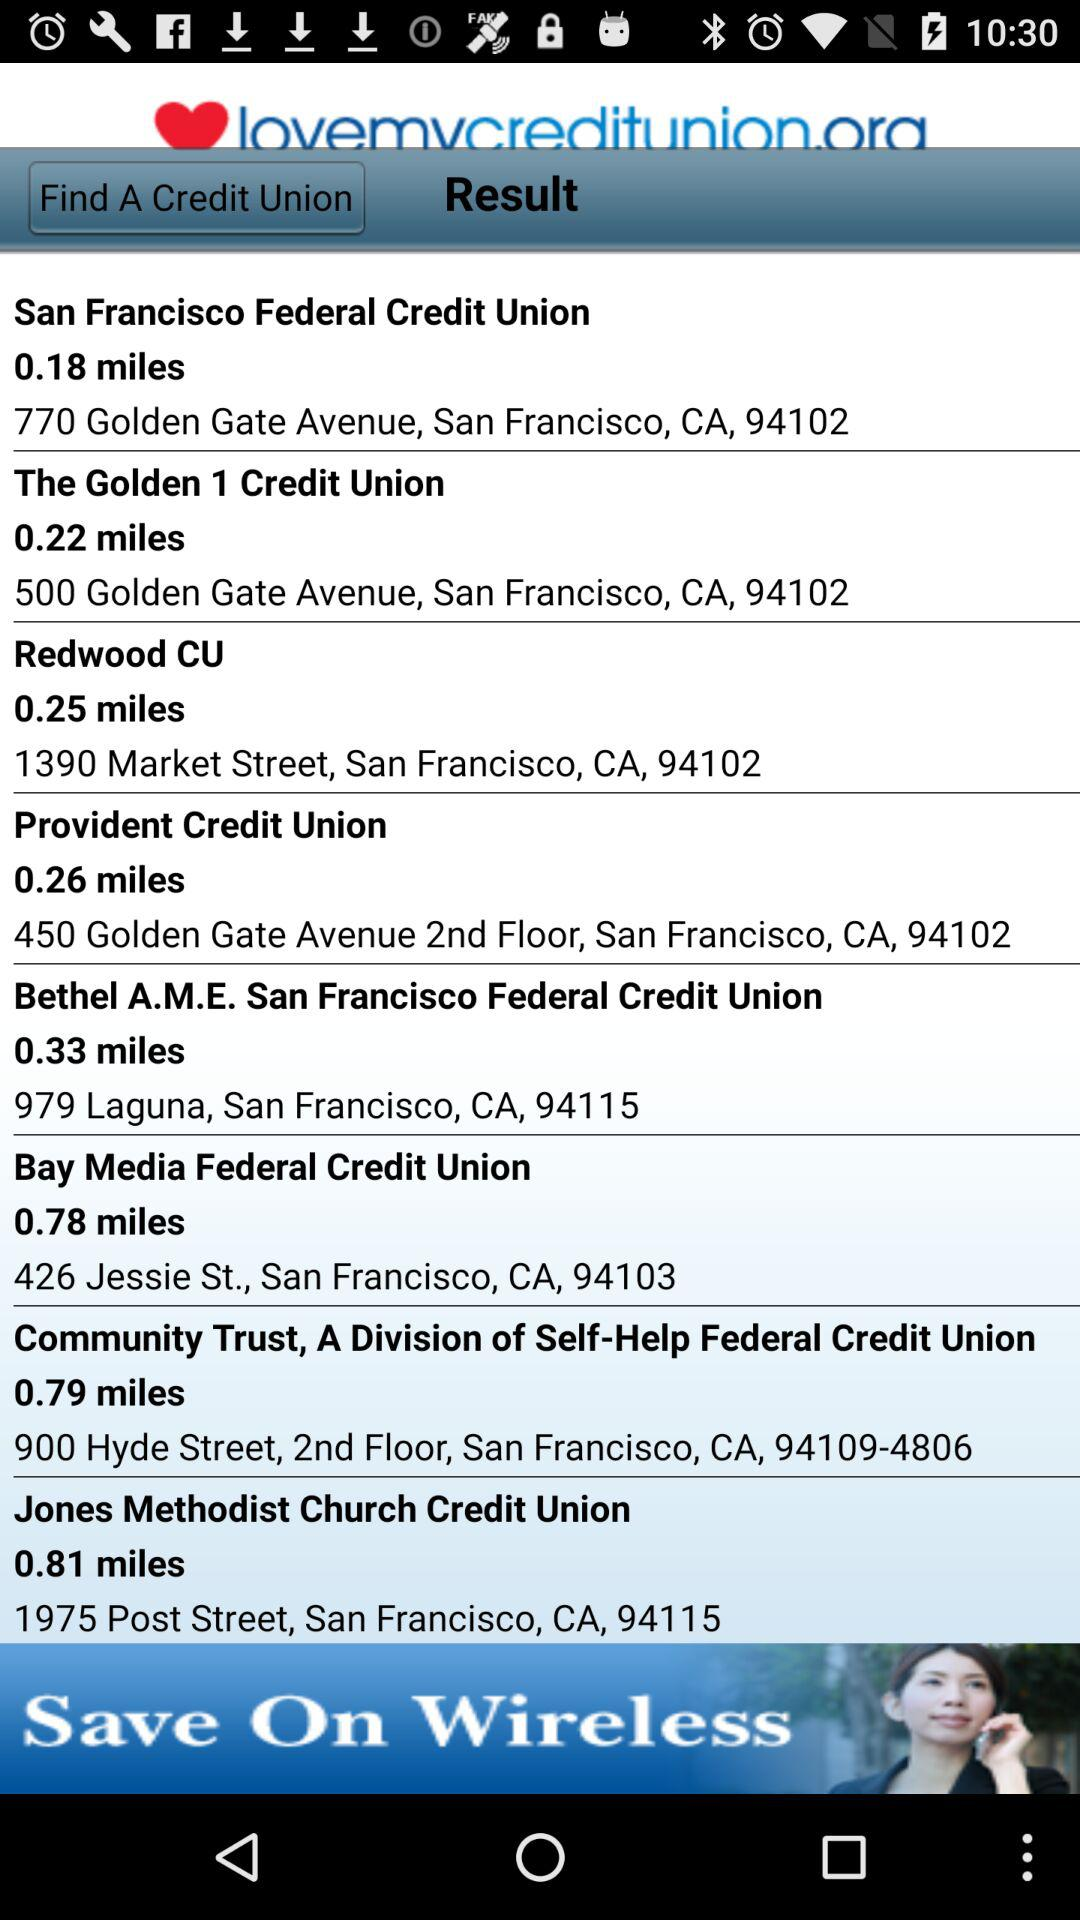How many miles away is the "Bay Media Federal Credit Union"? The "Bay Media Federal Credit Union" is 0.78 miles away. 